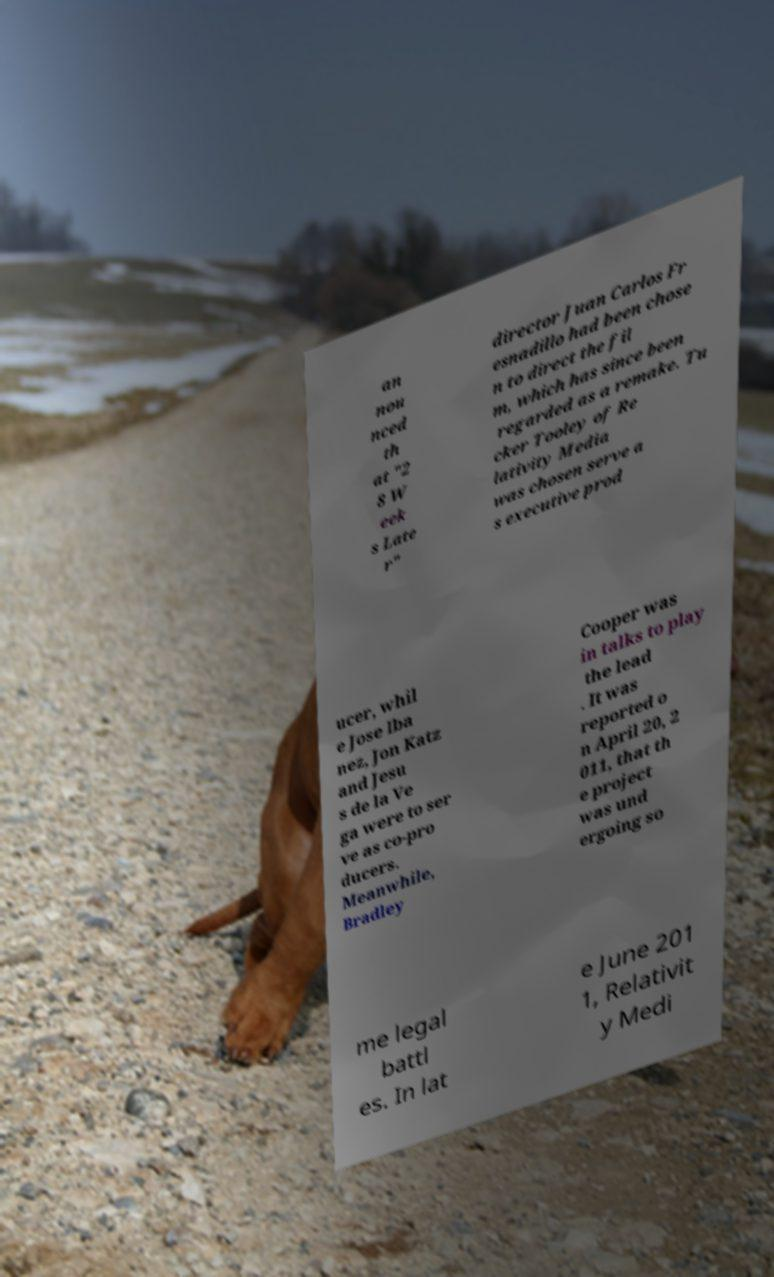Please read and relay the text visible in this image. What does it say? an nou nced th at "2 8 W eek s Late r" director Juan Carlos Fr esnadillo had been chose n to direct the fil m, which has since been regarded as a remake. Tu cker Tooley of Re lativity Media was chosen serve a s executive prod ucer, whil e Jose Iba nez, Jon Katz and Jesu s de la Ve ga were to ser ve as co-pro ducers. Meanwhile, Bradley Cooper was in talks to play the lead . It was reported o n April 20, 2 011, that th e project was und ergoing so me legal battl es. In lat e June 201 1, Relativit y Medi 